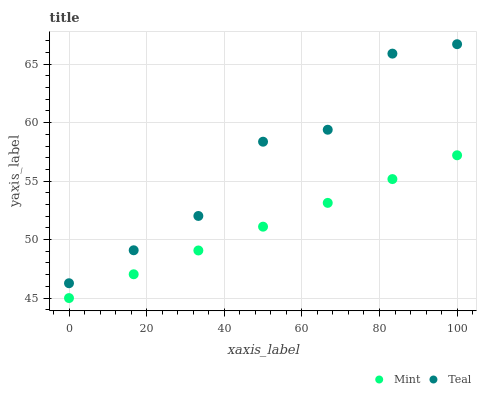Does Mint have the minimum area under the curve?
Answer yes or no. Yes. Does Teal have the maximum area under the curve?
Answer yes or no. Yes. Does Teal have the minimum area under the curve?
Answer yes or no. No. Is Mint the smoothest?
Answer yes or no. Yes. Is Teal the roughest?
Answer yes or no. Yes. Is Teal the smoothest?
Answer yes or no. No. Does Mint have the lowest value?
Answer yes or no. Yes. Does Teal have the lowest value?
Answer yes or no. No. Does Teal have the highest value?
Answer yes or no. Yes. Is Mint less than Teal?
Answer yes or no. Yes. Is Teal greater than Mint?
Answer yes or no. Yes. Does Mint intersect Teal?
Answer yes or no. No. 